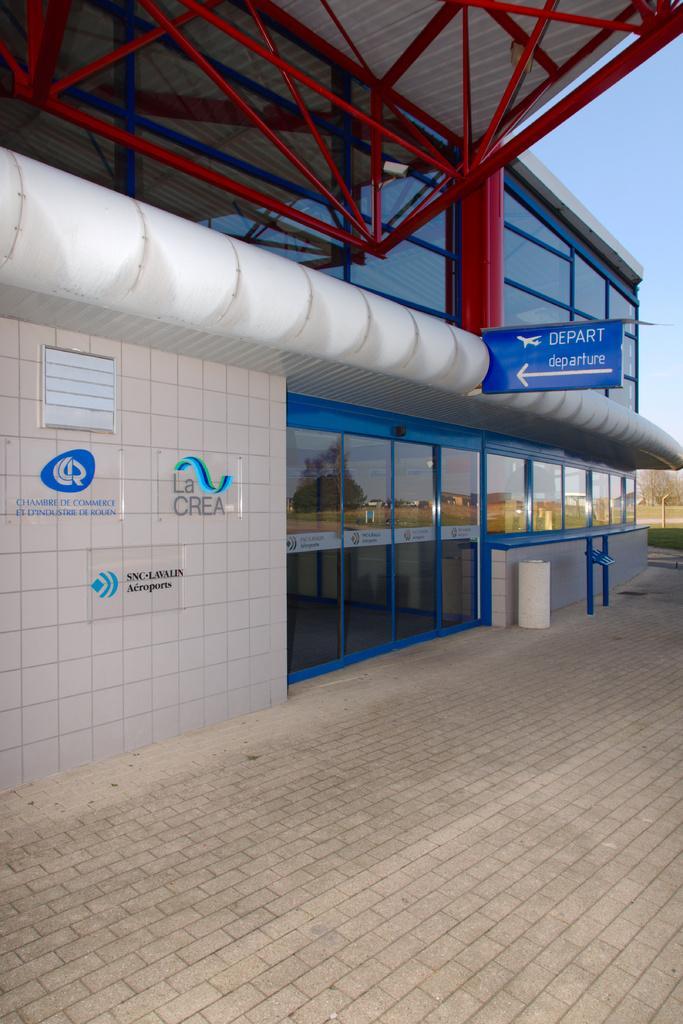In one or two sentences, can you explain what this image depicts? In this image there is a signboard and logo frames attached to the building, there are a few reflections of trees and houses on the windows of the building, there are trees and the sky. 